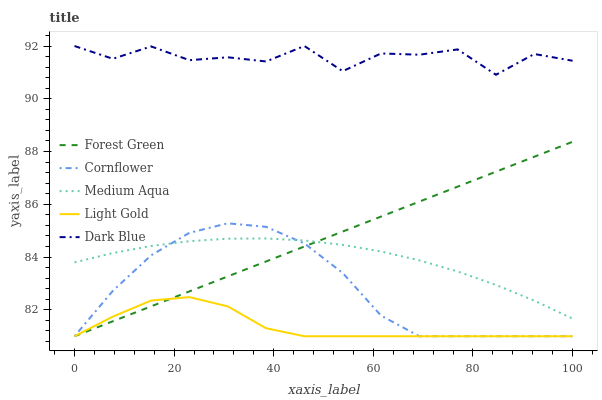Does Light Gold have the minimum area under the curve?
Answer yes or no. Yes. Does Dark Blue have the maximum area under the curve?
Answer yes or no. Yes. Does Forest Green have the minimum area under the curve?
Answer yes or no. No. Does Forest Green have the maximum area under the curve?
Answer yes or no. No. Is Forest Green the smoothest?
Answer yes or no. Yes. Is Dark Blue the roughest?
Answer yes or no. Yes. Is Light Gold the smoothest?
Answer yes or no. No. Is Light Gold the roughest?
Answer yes or no. No. Does Cornflower have the lowest value?
Answer yes or no. Yes. Does Medium Aqua have the lowest value?
Answer yes or no. No. Does Dark Blue have the highest value?
Answer yes or no. Yes. Does Forest Green have the highest value?
Answer yes or no. No. Is Cornflower less than Dark Blue?
Answer yes or no. Yes. Is Dark Blue greater than Light Gold?
Answer yes or no. Yes. Does Cornflower intersect Medium Aqua?
Answer yes or no. Yes. Is Cornflower less than Medium Aqua?
Answer yes or no. No. Is Cornflower greater than Medium Aqua?
Answer yes or no. No. Does Cornflower intersect Dark Blue?
Answer yes or no. No. 